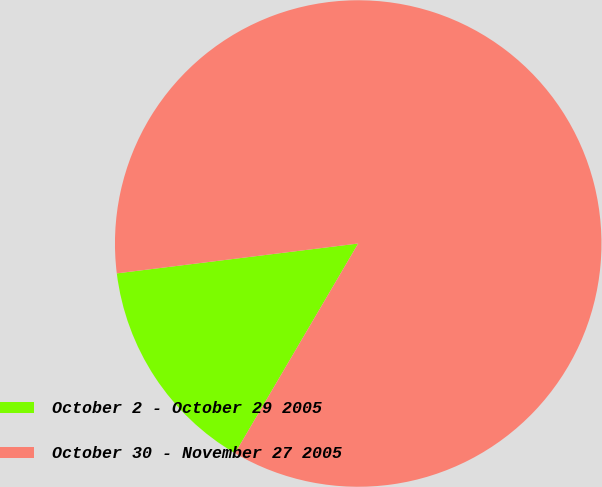<chart> <loc_0><loc_0><loc_500><loc_500><pie_chart><fcel>October 2 - October 29 2005<fcel>October 30 - November 27 2005<nl><fcel>14.59%<fcel>85.41%<nl></chart> 